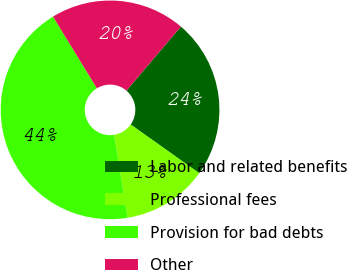Convert chart. <chart><loc_0><loc_0><loc_500><loc_500><pie_chart><fcel>Labor and related benefits<fcel>Professional fees<fcel>Provision for bad debts<fcel>Other<nl><fcel>23.62%<fcel>12.6%<fcel>43.83%<fcel>19.95%<nl></chart> 